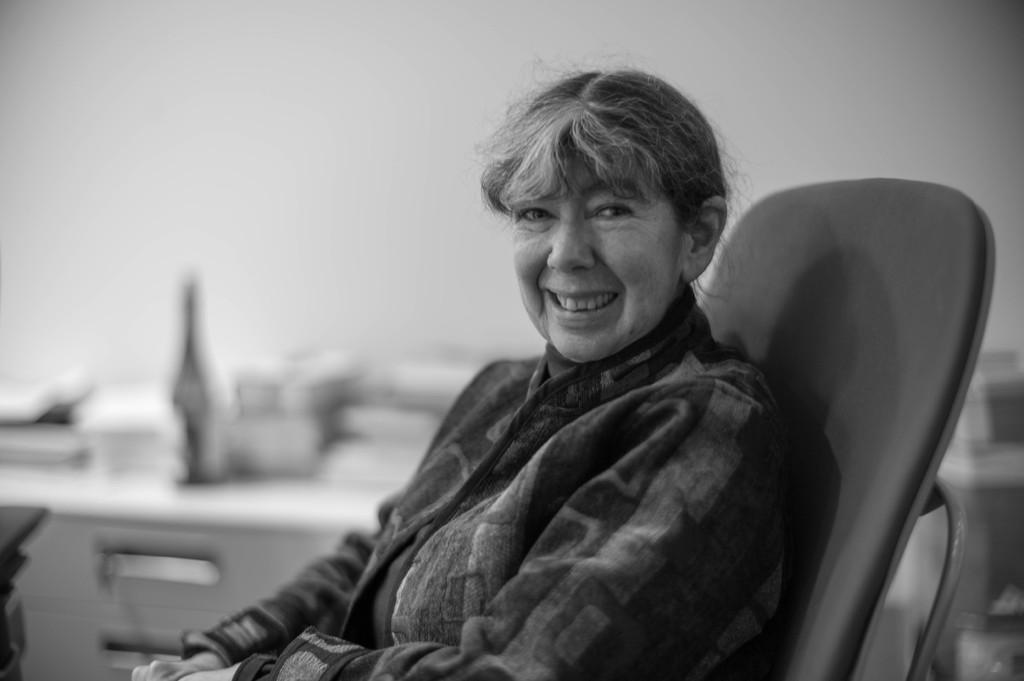Who is present in the image? There is a woman in the image. What is the woman doing in the image? The woman is sitting on a chair and smiling. What can be seen in the background of the image? There are bottles, drawers of a desk, and a wall in the background of the image. How is the image quality? The image is blurry. What type of music is the band playing in the background of the image? There is no band present in the image, so it is not possible to determine what type of music they might be playing. 